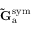Convert formula to latex. <formula><loc_0><loc_0><loc_500><loc_500>\tilde { G } _ { a } ^ { s y m }</formula> 